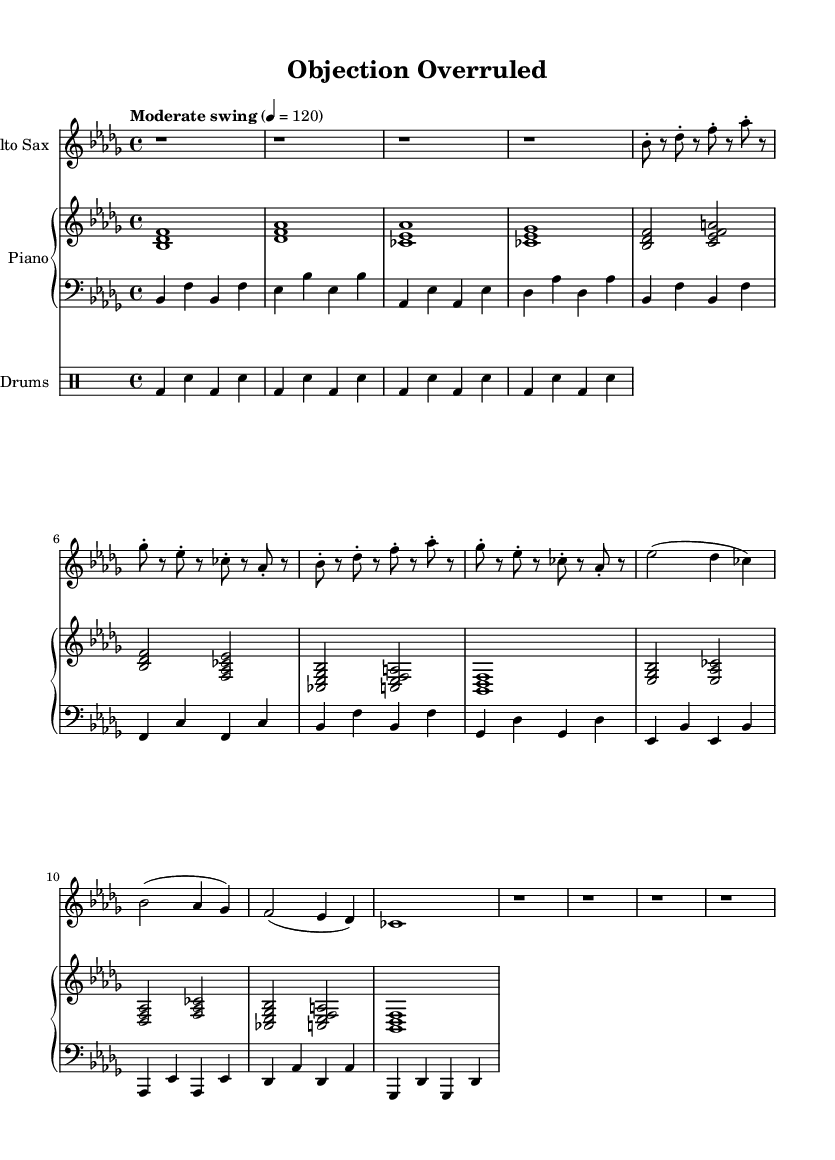What is the key signature of this music? The key signature is determined by the presence of the flat symbols in the music. In this sheet music, there are five flat symbols, indicating that it is in B flat minor.
Answer: B flat minor What is the time signature of this piece? The time signature is indicated at the beginning of the score, where it shows 4/4, which means there are four beats in each measure and the quarter note receives one beat.
Answer: 4/4 What is the tempo marking for this piece? The tempo is indicated at the beginning with the phrase "Moderate swing" followed by a metronome marking of 120 beats per minute, which directs the performers on the intended speed of the piece.
Answer: Moderate swing, 120 How many measures are in the A section? The A section can be identified by examining the music: it consists of four measures as presented in the sheet music view: one for each time the melody is played.
Answer: 4 What chord is played during the intro on the piano? The intro section of the piano part contains three-note chords, the first being a B flat major chord which includes the notes B flat, D, and F, indicating the harmonic foundation for the intro.
Answer: B flat major What is the rhythmic pattern played by the drums? The drum part is structured in a repetitive pattern consisting of bass drum and snare drum hits evenly spaced, showcasing a standard jazz rhythm, which can be analyzed by looking at the notation in the drum section.
Answer: Bass and snare alternating How does the piece reflect jazz fusion characteristics? The piece combines elements of improvisation and complex harmonic structures typical of jazz fusion, shown in both the saxophone solo section and the varied chord progressions in the piano part; these features emphasize the blending of jazz with other genres.
Answer: Improvisation and complex harmony 